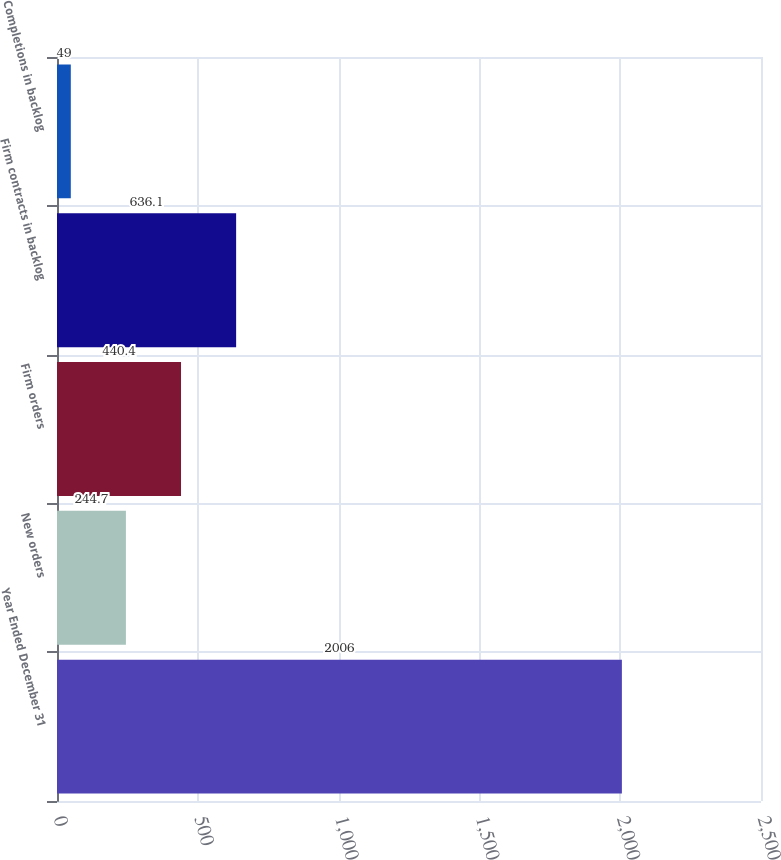Convert chart. <chart><loc_0><loc_0><loc_500><loc_500><bar_chart><fcel>Year Ended December 31<fcel>New orders<fcel>Firm orders<fcel>Firm contracts in backlog<fcel>Completions in backlog<nl><fcel>2006<fcel>244.7<fcel>440.4<fcel>636.1<fcel>49<nl></chart> 